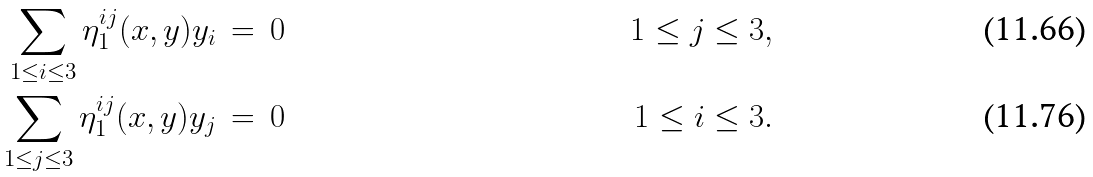<formula> <loc_0><loc_0><loc_500><loc_500>\sum _ { 1 \leq i \leq 3 } \eta _ { 1 } ^ { i j } ( x , y ) y _ { i } \, & = \, 0 \quad & 1 \leq j \leq 3 , \\ \sum _ { 1 \leq j \leq 3 } \eta _ { 1 } ^ { i j } ( x , y ) y _ { j } \, & = \, 0 \quad & 1 \leq i \leq 3 .</formula> 